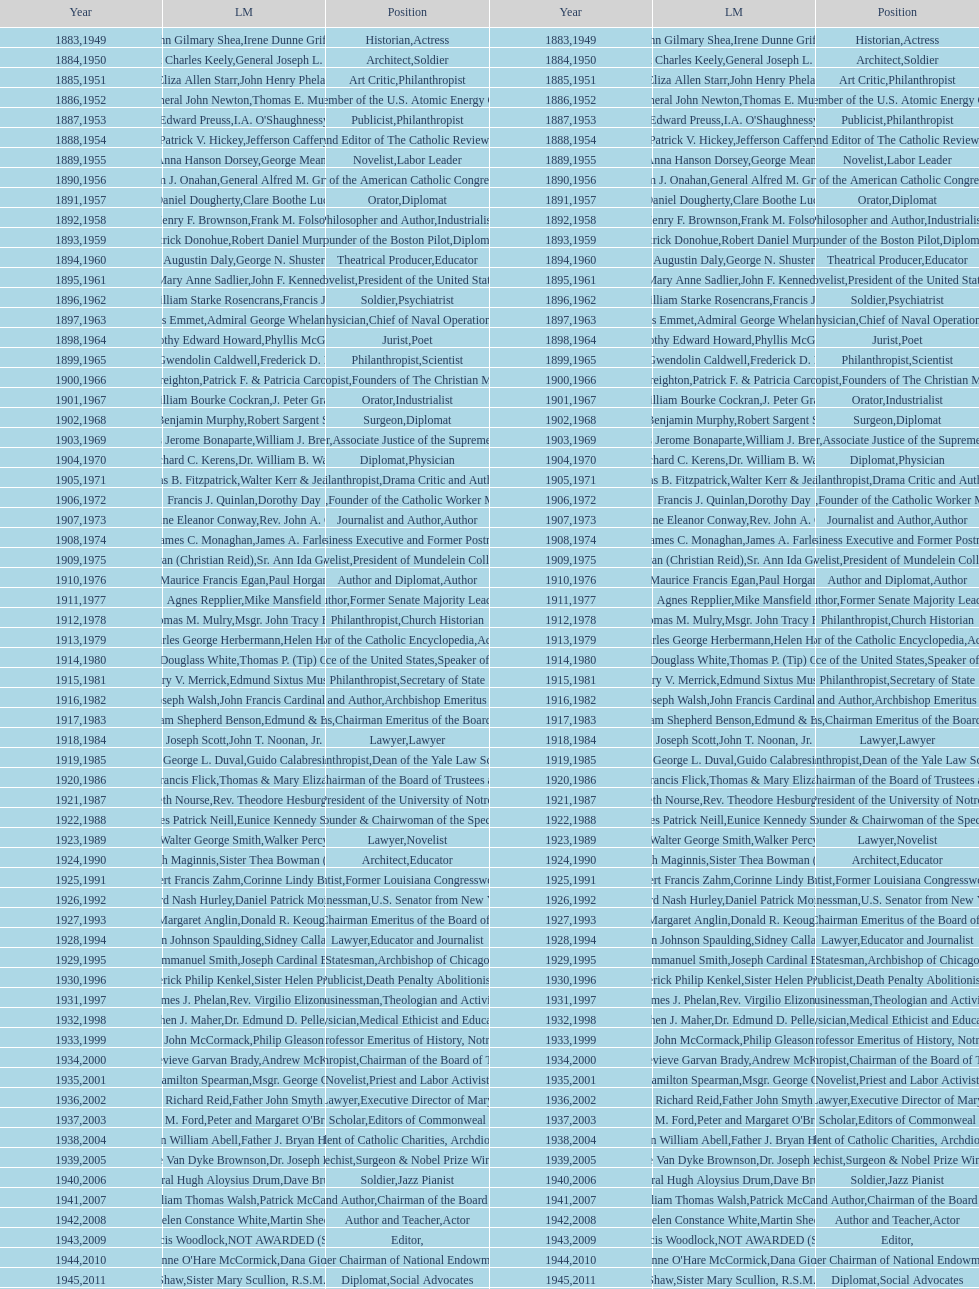Who won the medal after thomas e. murray in 1952? I.A. O'Shaughnessy. 